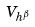Convert formula to latex. <formula><loc_0><loc_0><loc_500><loc_500>V _ { h ^ { \beta } }</formula> 